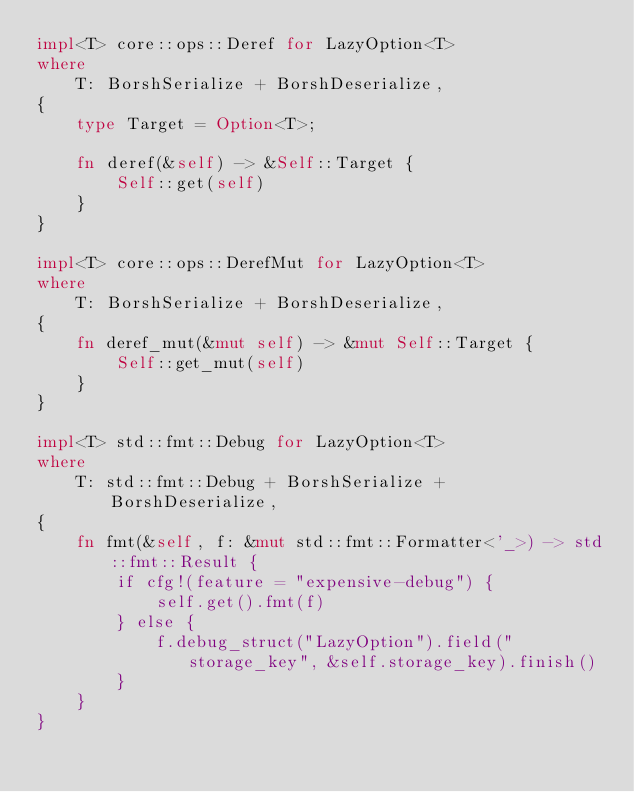Convert code to text. <code><loc_0><loc_0><loc_500><loc_500><_Rust_>impl<T> core::ops::Deref for LazyOption<T>
where
    T: BorshSerialize + BorshDeserialize,
{
    type Target = Option<T>;

    fn deref(&self) -> &Self::Target {
        Self::get(self)
    }
}

impl<T> core::ops::DerefMut for LazyOption<T>
where
    T: BorshSerialize + BorshDeserialize,
{
    fn deref_mut(&mut self) -> &mut Self::Target {
        Self::get_mut(self)
    }
}

impl<T> std::fmt::Debug for LazyOption<T>
where
    T: std::fmt::Debug + BorshSerialize + BorshDeserialize,
{
    fn fmt(&self, f: &mut std::fmt::Formatter<'_>) -> std::fmt::Result {
        if cfg!(feature = "expensive-debug") {
            self.get().fmt(f)
        } else {
            f.debug_struct("LazyOption").field("storage_key", &self.storage_key).finish()
        }
    }
}
</code> 